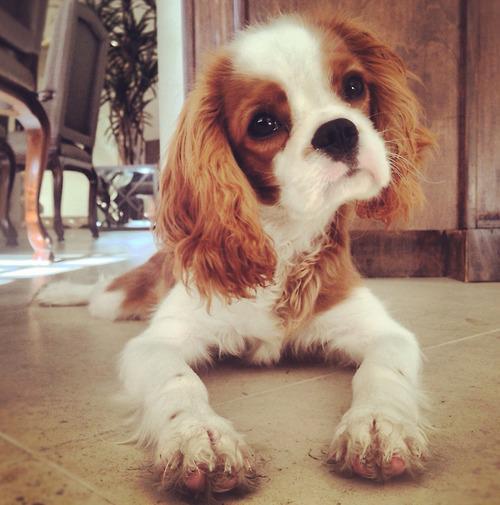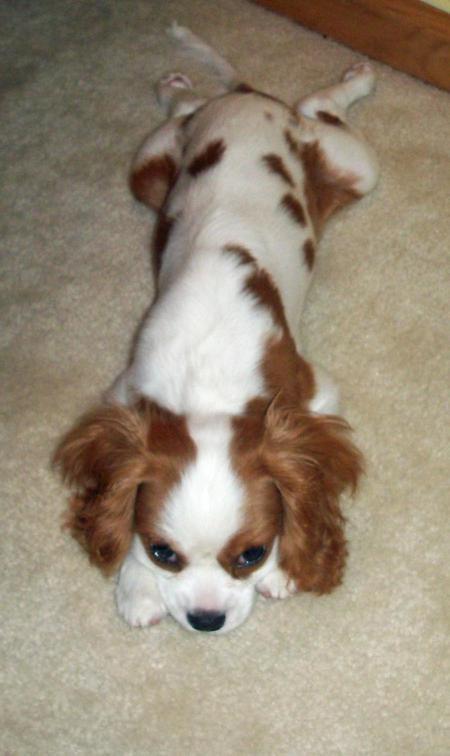The first image is the image on the left, the second image is the image on the right. Analyze the images presented: Is the assertion "There is a total of 1 collar on a small dog." valid? Answer yes or no. No. The first image is the image on the left, the second image is the image on the right. Analyze the images presented: Is the assertion "A brown and white puppy has its head cocked to the left." valid? Answer yes or no. Yes. 